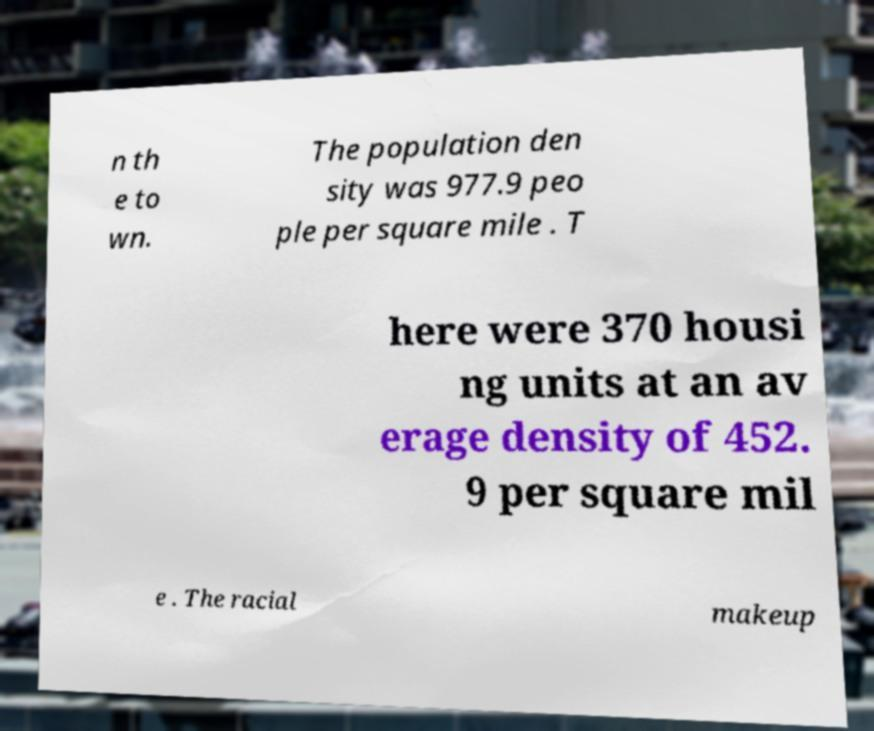Could you extract and type out the text from this image? n th e to wn. The population den sity was 977.9 peo ple per square mile . T here were 370 housi ng units at an av erage density of 452. 9 per square mil e . The racial makeup 